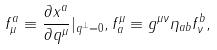Convert formula to latex. <formula><loc_0><loc_0><loc_500><loc_500>f _ { \mu } ^ { a } \equiv \frac { \partial x ^ { a } } { \partial q ^ { \mu } } | _ { q ^ { \perp } = 0 } , f _ { a } ^ { \mu } \equiv g ^ { \mu \nu } \eta _ { a b } f _ { \nu } ^ { b } ,</formula> 